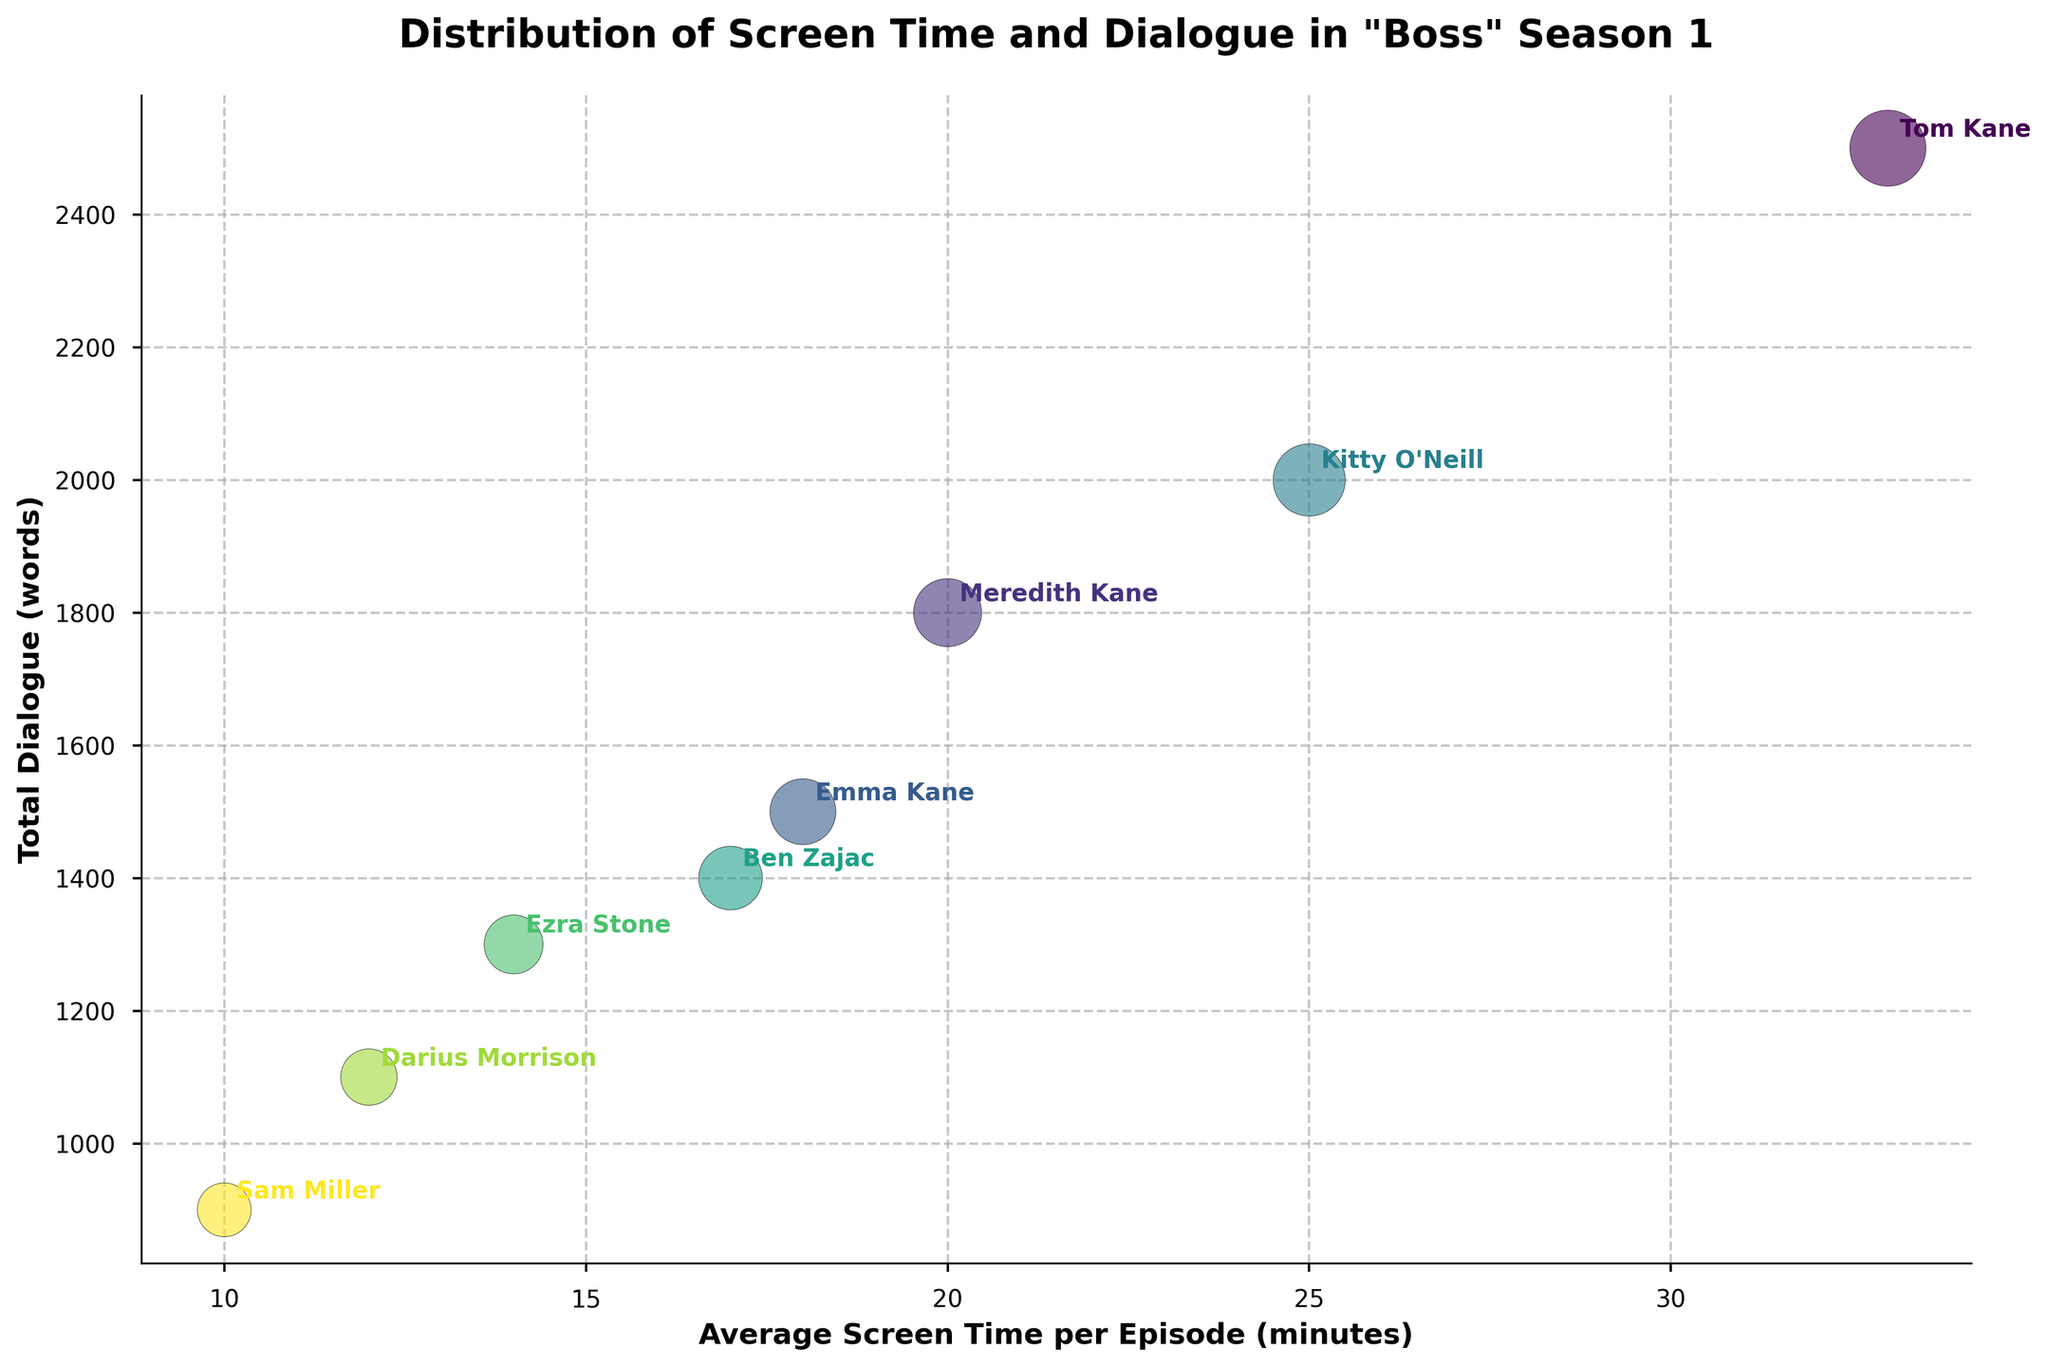What is the title of the figure? The title of the figure is displayed prominently at the top and provides an overview of what the chart represents.
Answer: Distribution of Screen Time and Dialogue in "Boss" Season 1 Which axis represents the average screen time per episode? The axis labeled with 'Average Screen Time per Episode (minutes)' indicates the corresponding variable being displayed. This label is on the x-axis.
Answer: x-axis How many main characters are displayed in the figure? By counting the annotated labels representing each main character, we can determine the total number.
Answer: 8 Who has the largest bubble in the chart? The largest bubble correlates with the biggest bubble size on the chart. Tom Kane's bubble is the largest, indicating the highest screen time and total dialogue.
Answer: Tom Kane How does Kitty O'Neill's average screen time compare to Meredith Kane's? By looking at the x-axis values for both Kitty O'Neill and Meredith Kane, we can compare their average screen times. Kitty O'Neill's screen time is 25 minutes, while Meredith Kane's is 20 minutes. Thus, Kitty O'Neill has more screen time.
Answer: Kitty O'Neill has more screen time than Meredith Kane What's the maximum average screen time shown on the x-axis? The furthest point along the x-axis represents the maximum average screen time in the dataset. Tom Kane's screen time of 33 minutes is the highest value on the x-axis.
Answer: 33 minutes Which character has the least total dialogue? By looking at the y-axis values for the different characters and identifying the smallest value, we find that Sam Miller has 900 words of dialogue, the least among the characters.
Answer: Sam Miller Who has more total dialogue: Emma Kane or Ben Zajac? By comparing the y-axis values for both Emma Kane and Ben Zajac, Emma Kane has 1500 words of dialogue, and Ben Zajac has 1400. Therefore, Emma Kane has more dialogue.
Answer: Emma Kane has more dialogue What is the combined average screen time of the characters with the two largest bubbles? The two largest bubbles represent Tom Kane and Kitty O'Neill, with average screen times of 33 and 25 minutes respectively. Adding these together gives us 58 minutes.
Answer: 58 minutes Who plays the character with the fourth largest bubble? The bubble sizes correspond to the values listed under the Bubble Size column. The fourth largest bubble belongs to Kitty O'Neill with 90 size, indicating the actress is Kathleen Robertson.
Answer: Kathleen Robertson 